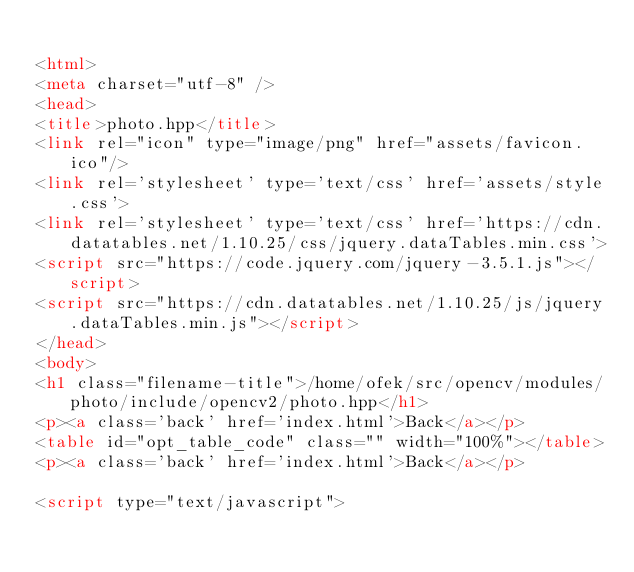<code> <loc_0><loc_0><loc_500><loc_500><_HTML_>
<html>
<meta charset="utf-8" />
<head>
<title>photo.hpp</title>
<link rel="icon" type="image/png" href="assets/favicon.ico"/>
<link rel='stylesheet' type='text/css' href='assets/style.css'>
<link rel='stylesheet' type='text/css' href='https://cdn.datatables.net/1.10.25/css/jquery.dataTables.min.css'>
<script src="https://code.jquery.com/jquery-3.5.1.js"></script>
<script src="https://cdn.datatables.net/1.10.25/js/jquery.dataTables.min.js"></script>
</head>
<body>
<h1 class="filename-title">/home/ofek/src/opencv/modules/photo/include/opencv2/photo.hpp</h1>
<p><a class='back' href='index.html'>Back</a></p>
<table id="opt_table_code" class="" width="100%"></table>
<p><a class='back' href='index.html'>Back</a></p>

<script type="text/javascript"></code> 